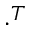<formula> <loc_0><loc_0><loc_500><loc_500>\cdot ^ { T }</formula> 